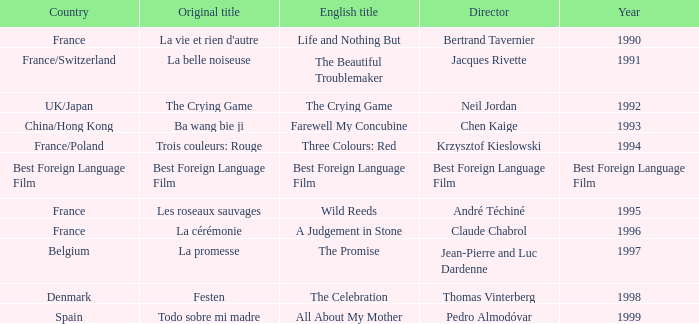Who is the Director of the Original title of The Crying Game? Neil Jordan. 